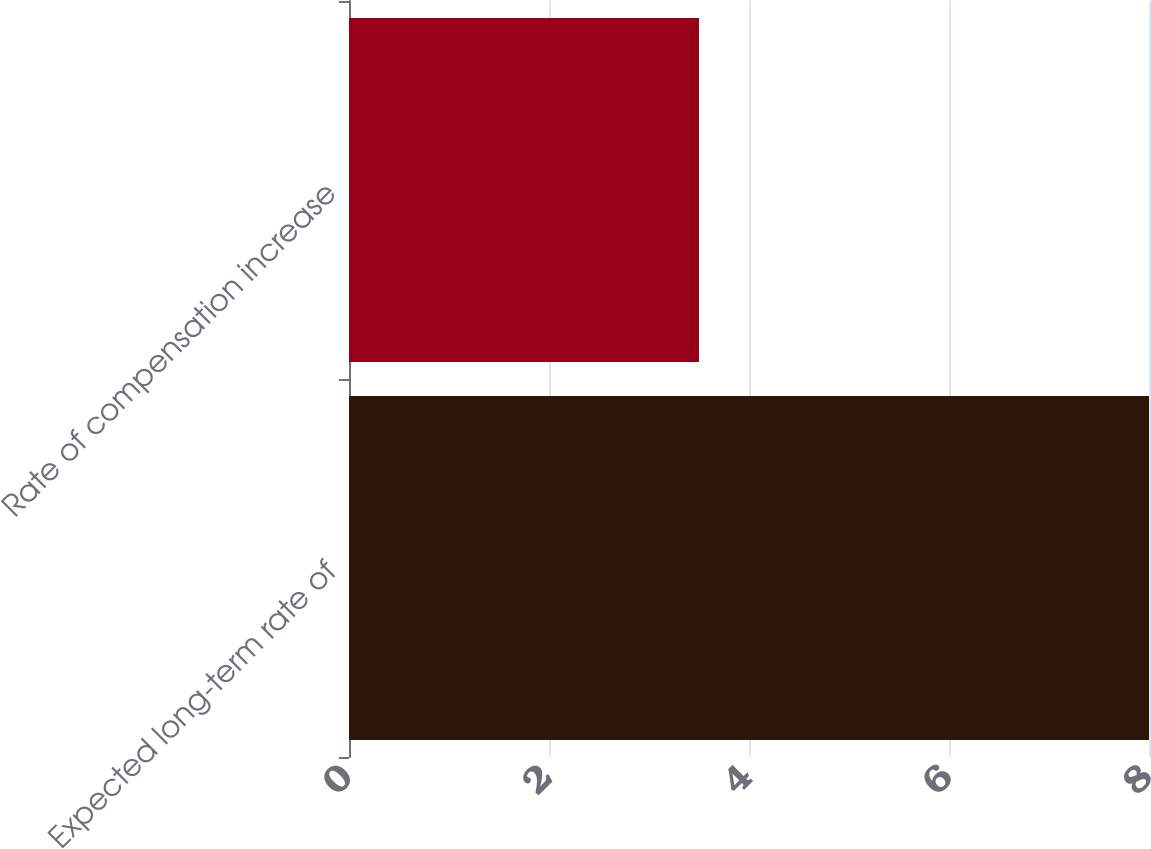<chart> <loc_0><loc_0><loc_500><loc_500><bar_chart><fcel>Expected long-term rate of<fcel>Rate of compensation increase<nl><fcel>8<fcel>3.5<nl></chart> 